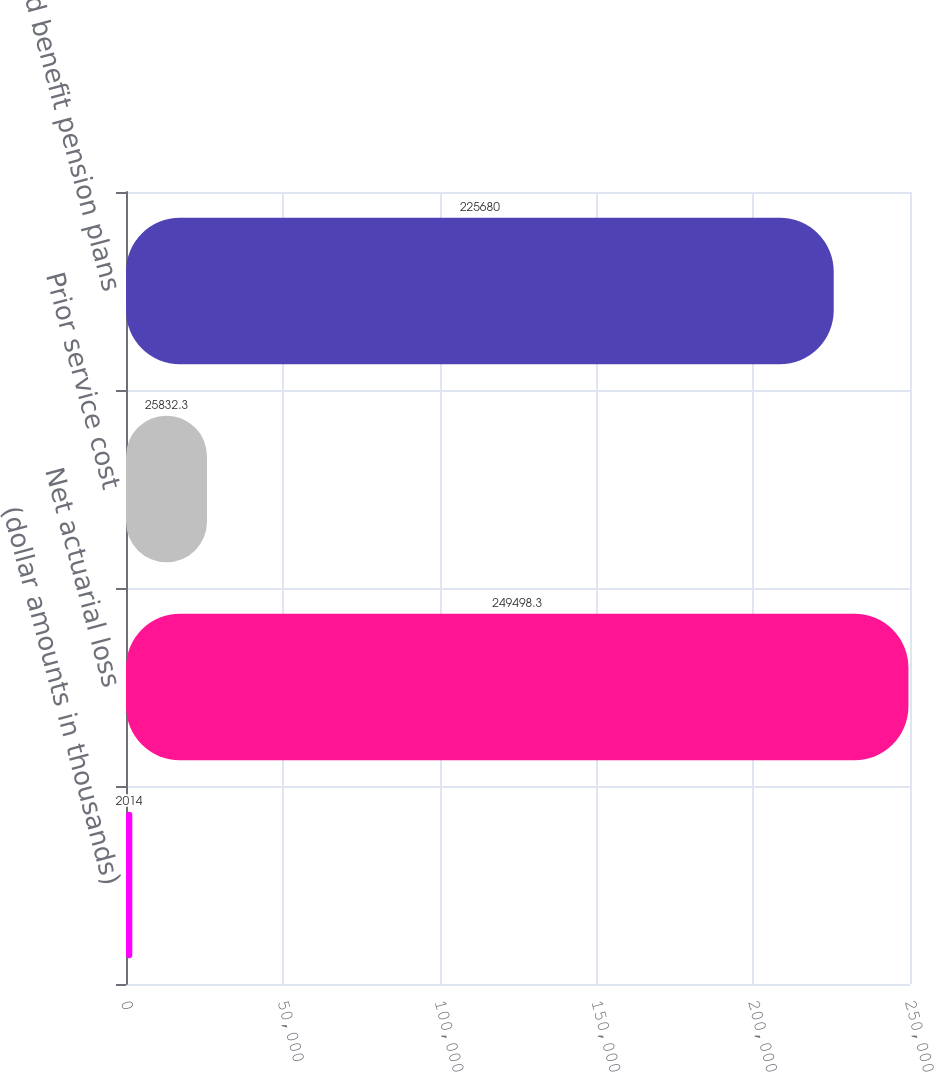Convert chart. <chart><loc_0><loc_0><loc_500><loc_500><bar_chart><fcel>(dollar amounts in thousands)<fcel>Net actuarial loss<fcel>Prior service cost<fcel>Defined benefit pension plans<nl><fcel>2014<fcel>249498<fcel>25832.3<fcel>225680<nl></chart> 